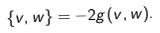<formula> <loc_0><loc_0><loc_500><loc_500>\left \{ v , w \right \} = - 2 g ( v , w ) .</formula> 